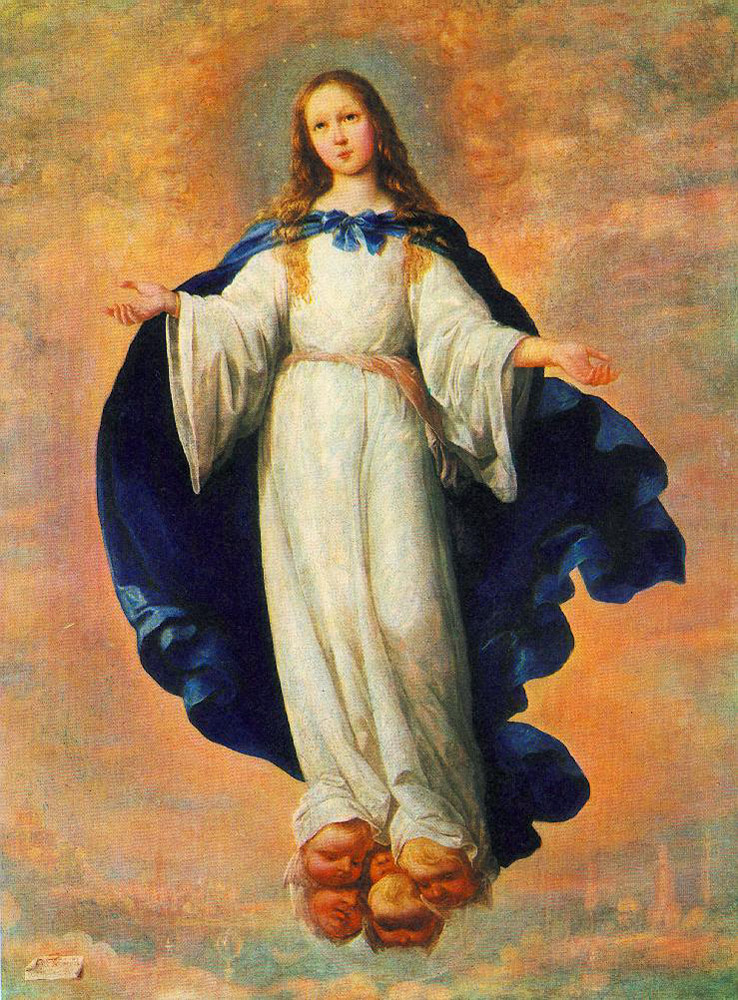Can you tell more about the symbolism of the blue cloak in this artwork? The blue cloak in this painting symbolizes tranquility, grace, and divinity. In many religious artworks, blue is a color often associated with the heavenly realm and is used to denote holiness and virtue. The expansive nature of the cloak, enveloping the figure, may also suggest protection or embrace, reinforcing the painting's spiritual theme. 